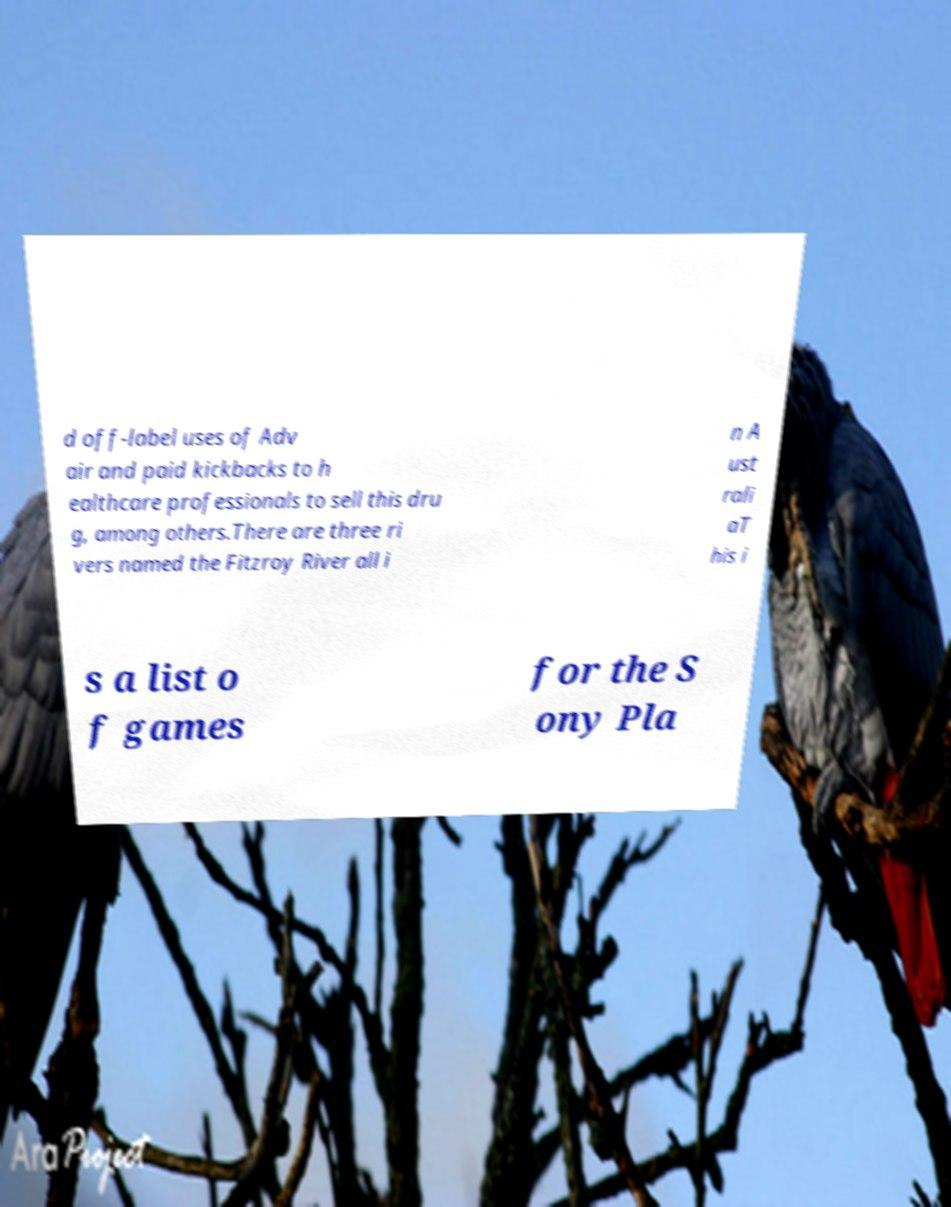There's text embedded in this image that I need extracted. Can you transcribe it verbatim? d off-label uses of Adv air and paid kickbacks to h ealthcare professionals to sell this dru g, among others.There are three ri vers named the Fitzroy River all i n A ust rali aT his i s a list o f games for the S ony Pla 